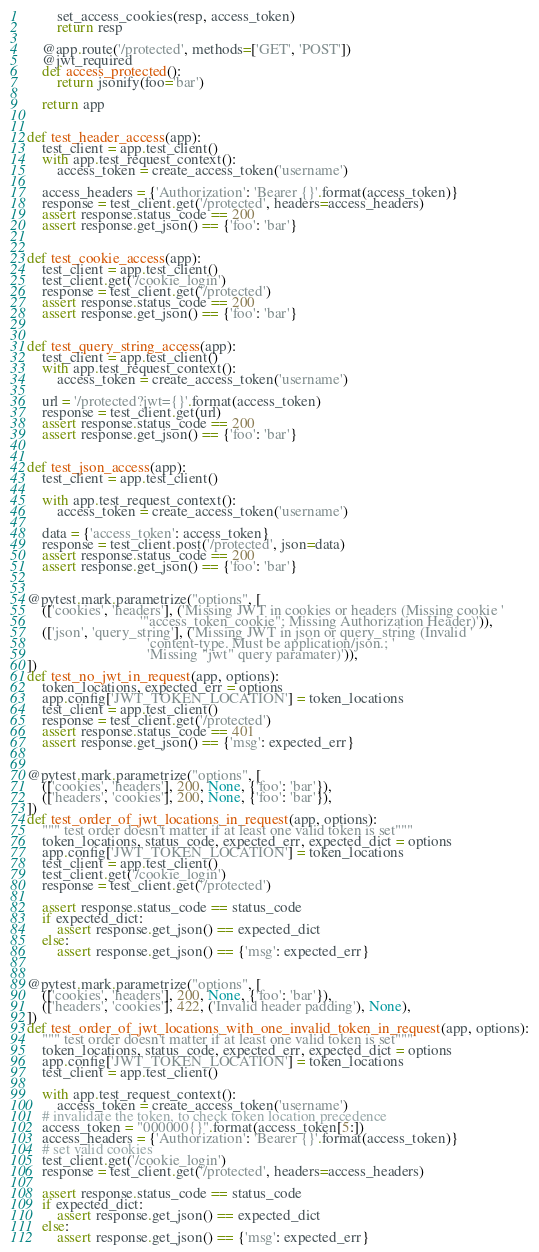<code> <loc_0><loc_0><loc_500><loc_500><_Python_>        set_access_cookies(resp, access_token)
        return resp

    @app.route('/protected', methods=['GET', 'POST'])
    @jwt_required
    def access_protected():
        return jsonify(foo='bar')

    return app


def test_header_access(app):
    test_client = app.test_client()
    with app.test_request_context():
        access_token = create_access_token('username')

    access_headers = {'Authorization': 'Bearer {}'.format(access_token)}
    response = test_client.get('/protected', headers=access_headers)
    assert response.status_code == 200
    assert response.get_json() == {'foo': 'bar'}


def test_cookie_access(app):
    test_client = app.test_client()
    test_client.get('/cookie_login')
    response = test_client.get('/protected')
    assert response.status_code == 200
    assert response.get_json() == {'foo': 'bar'}


def test_query_string_access(app):
    test_client = app.test_client()
    with app.test_request_context():
        access_token = create_access_token('username')

    url = '/protected?jwt={}'.format(access_token)
    response = test_client.get(url)
    assert response.status_code == 200
    assert response.get_json() == {'foo': 'bar'}


def test_json_access(app):
    test_client = app.test_client()

    with app.test_request_context():
        access_token = create_access_token('username')

    data = {'access_token': access_token}
    response = test_client.post('/protected', json=data)
    assert response.status_code == 200
    assert response.get_json() == {'foo': 'bar'}


@pytest.mark.parametrize("options", [
    (['cookies', 'headers'], ('Missing JWT in cookies or headers (Missing cookie '
                              '"access_token_cookie"; Missing Authorization Header)')),
    (['json', 'query_string'], ('Missing JWT in json or query_string (Invalid '
                                'content-type. Must be application/json.; '
                                'Missing "jwt" query paramater)')),
])
def test_no_jwt_in_request(app, options):
    token_locations, expected_err = options
    app.config['JWT_TOKEN_LOCATION'] = token_locations
    test_client = app.test_client()
    response = test_client.get('/protected')
    assert response.status_code == 401
    assert response.get_json() == {'msg': expected_err}


@pytest.mark.parametrize("options", [
    (['cookies', 'headers'], 200, None, {'foo': 'bar'}),
    (['headers', 'cookies'], 200, None, {'foo': 'bar'}),
])
def test_order_of_jwt_locations_in_request(app, options):
    """ test order doesn't matter if at least one valid token is set"""
    token_locations, status_code, expected_err, expected_dict = options
    app.config['JWT_TOKEN_LOCATION'] = token_locations
    test_client = app.test_client()
    test_client.get('/cookie_login')
    response = test_client.get('/protected')

    assert response.status_code == status_code
    if expected_dict:
        assert response.get_json() == expected_dict
    else:
        assert response.get_json() == {'msg': expected_err}


@pytest.mark.parametrize("options", [
    (['cookies', 'headers'], 200, None, {'foo': 'bar'}),
    (['headers', 'cookies'], 422, ('Invalid header padding'), None),
])
def test_order_of_jwt_locations_with_one_invalid_token_in_request(app, options):
    """ test order doesn't matter if at least one valid token is set"""
    token_locations, status_code, expected_err, expected_dict = options
    app.config['JWT_TOKEN_LOCATION'] = token_locations
    test_client = app.test_client()

    with app.test_request_context():
        access_token = create_access_token('username')
    # invalidate the token, to check token location precedence
    access_token = "000000{}".format(access_token[5:])
    access_headers = {'Authorization': 'Bearer {}'.format(access_token)}
    # set valid cookies
    test_client.get('/cookie_login')
    response = test_client.get('/protected', headers=access_headers)

    assert response.status_code == status_code
    if expected_dict:
        assert response.get_json() == expected_dict
    else:
        assert response.get_json() == {'msg': expected_err}
</code> 